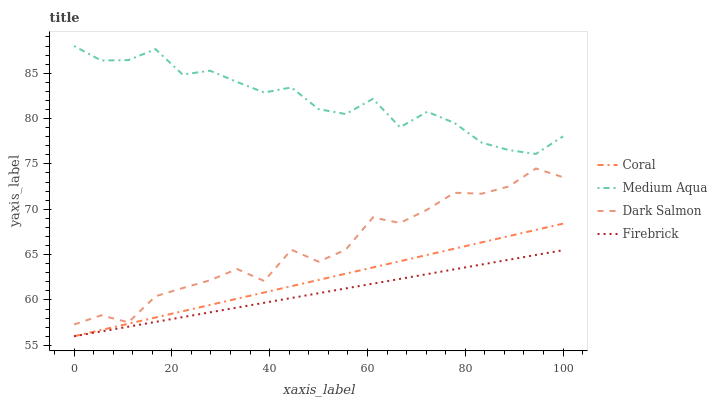Does Firebrick have the minimum area under the curve?
Answer yes or no. Yes. Does Medium Aqua have the maximum area under the curve?
Answer yes or no. Yes. Does Coral have the minimum area under the curve?
Answer yes or no. No. Does Coral have the maximum area under the curve?
Answer yes or no. No. Is Firebrick the smoothest?
Answer yes or no. Yes. Is Dark Salmon the roughest?
Answer yes or no. Yes. Is Coral the smoothest?
Answer yes or no. No. Is Coral the roughest?
Answer yes or no. No. Does Firebrick have the lowest value?
Answer yes or no. Yes. Does Medium Aqua have the lowest value?
Answer yes or no. No. Does Medium Aqua have the highest value?
Answer yes or no. Yes. Does Coral have the highest value?
Answer yes or no. No. Is Firebrick less than Medium Aqua?
Answer yes or no. Yes. Is Medium Aqua greater than Coral?
Answer yes or no. Yes. Does Firebrick intersect Coral?
Answer yes or no. Yes. Is Firebrick less than Coral?
Answer yes or no. No. Is Firebrick greater than Coral?
Answer yes or no. No. Does Firebrick intersect Medium Aqua?
Answer yes or no. No. 